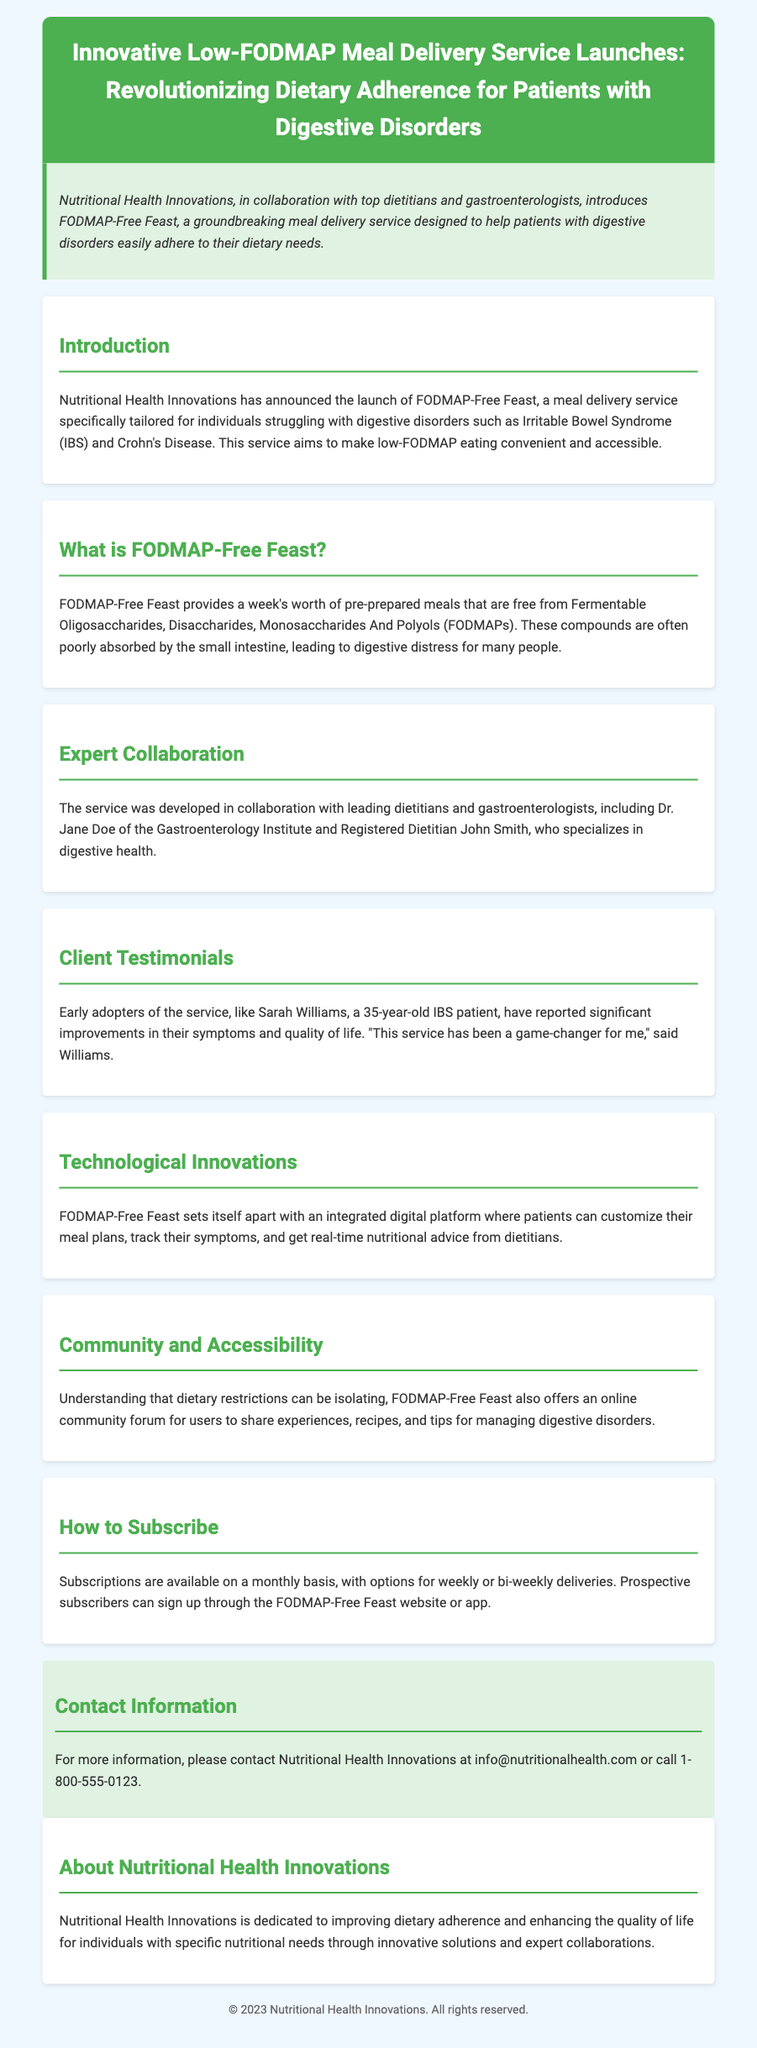What is the name of the meal delivery service? The name of the meal delivery service is FODMAP-Free Feast.
Answer: FODMAP-Free Feast Which disorders does the service cater to? The service caters to individuals struggling with Irritable Bowel Syndrome (IBS) and Crohn's Disease.
Answer: Irritable Bowel Syndrome (IBS) and Crohn's Disease Who developed the service? The service was developed in collaboration with leading dietitians and gastroenterologists, including Dr. Jane Doe and Registered Dietitian John Smith.
Answer: Dr. Jane Doe and Registered Dietitian John Smith What is the duration of meal provision offered? FODMAP-Free Feast provides a week's worth of pre-prepared meals.
Answer: A week's worth What experience did an early adopter mention? Sarah Williams, an early adopter, reported significant improvements in her symptoms and quality of life.
Answer: Significant improvements in symptoms and quality of life What features does the integrated digital platform include? The integrated digital platform allows patients to customize their meal plans, track their symptoms, and get real-time nutritional advice.
Answer: Customize meal plans, track symptoms, real-time nutritional advice What kind of community feature is included with the service? The service offers an online community forum for users to share experiences, recipes, and tips.
Answer: Online community forum How can subscribers sign up for the service? Subscriptions can be signed up through the FODMAP-Free Feast website or app.
Answer: FODMAP-Free Feast website or app What is the purpose of Nutritional Health Innovations? Nutritional Health Innovations is dedicated to improving dietary adherence and enhancing the quality of life for individuals with specific nutritional needs.
Answer: Improving dietary adherence and enhancing quality of life 